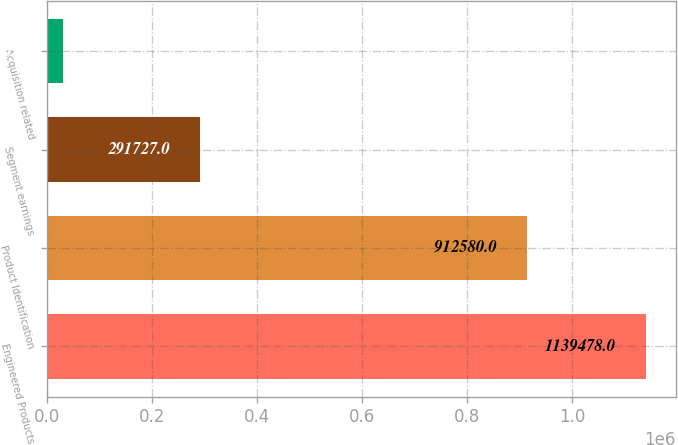<chart> <loc_0><loc_0><loc_500><loc_500><bar_chart><fcel>Engineered Products<fcel>Product Identification<fcel>Segment earnings<fcel>Acquisition related<nl><fcel>1.13948e+06<fcel>912580<fcel>291727<fcel>29262<nl></chart> 